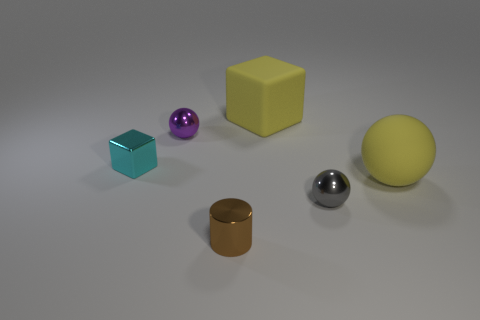There is a ball that is behind the tiny thing that is on the left side of the purple metallic thing; what is its material?
Give a very brief answer. Metal. What shape is the thing that is behind the large yellow sphere and on the right side of the cylinder?
Make the answer very short. Cube. What is the size of the yellow rubber thing that is the same shape as the gray shiny thing?
Your answer should be very brief. Large. Are there fewer tiny purple metallic balls that are on the right side of the large ball than big yellow objects?
Provide a succinct answer. Yes. There is a cube on the right side of the small block; what is its size?
Give a very brief answer. Large. What is the color of the big matte object that is the same shape as the small cyan metal object?
Make the answer very short. Yellow. How many big things are the same color as the big matte ball?
Provide a short and direct response. 1. Is there any other thing that is the same shape as the tiny brown shiny thing?
Provide a short and direct response. No. There is a cube on the left side of the small brown metallic thing that is to the left of the yellow sphere; are there any big yellow things that are in front of it?
Make the answer very short. Yes. How many large yellow spheres are the same material as the brown cylinder?
Give a very brief answer. 0. 